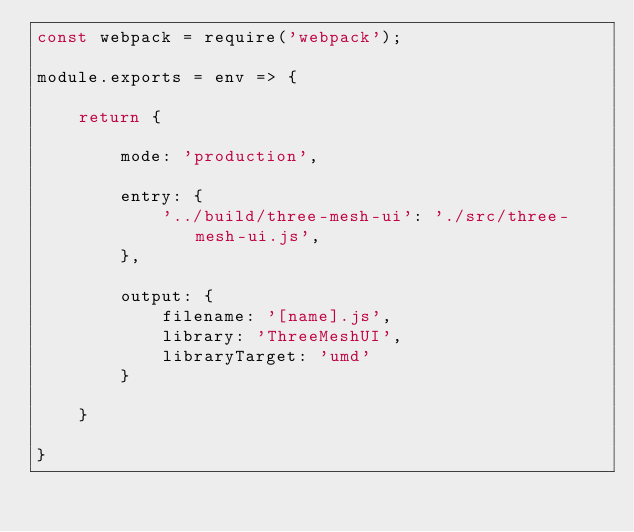<code> <loc_0><loc_0><loc_500><loc_500><_JavaScript_>const webpack = require('webpack');

module.exports = env => {

	return {

		mode: 'production',

		entry: {
			'../build/three-mesh-ui': './src/three-mesh-ui.js',
		},

		output: {
			filename: '[name].js',
			library: 'ThreeMeshUI',
			libraryTarget: 'umd'
		}

	}

}</code> 